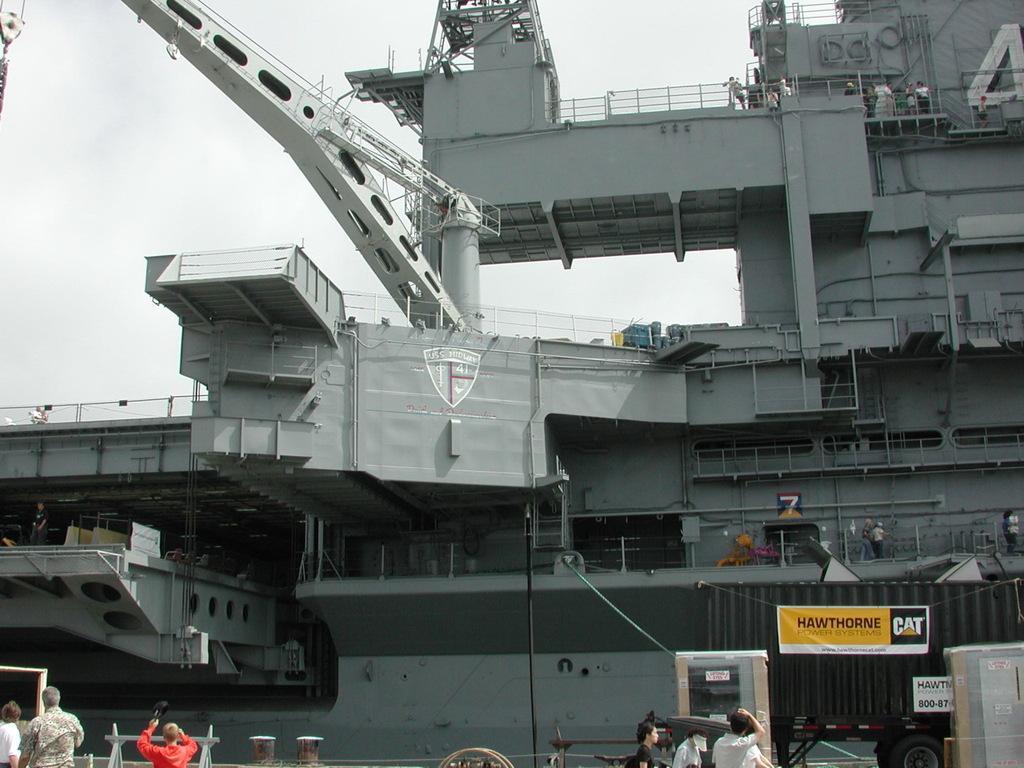In one or two sentences, can you explain what this image depicts? In this image I can see number of people on the all sides of this image. I can also see few boards on the right side and on it I can see something is written. In the background I can see a ship like thing. 